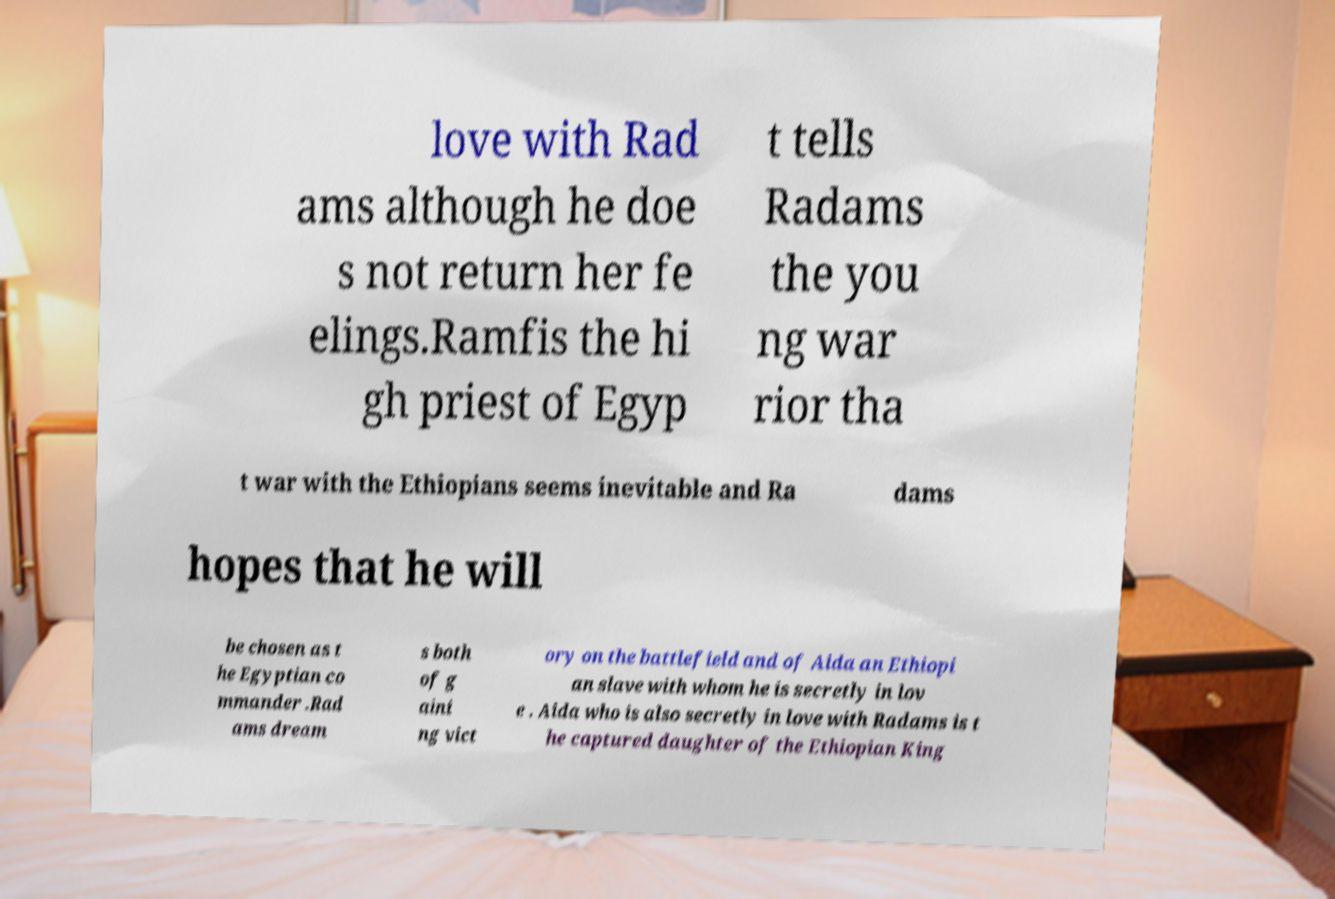Please read and relay the text visible in this image. What does it say? love with Rad ams although he doe s not return her fe elings.Ramfis the hi gh priest of Egyp t tells Radams the you ng war rior tha t war with the Ethiopians seems inevitable and Ra dams hopes that he will be chosen as t he Egyptian co mmander .Rad ams dream s both of g aini ng vict ory on the battlefield and of Aida an Ethiopi an slave with whom he is secretly in lov e . Aida who is also secretly in love with Radams is t he captured daughter of the Ethiopian King 